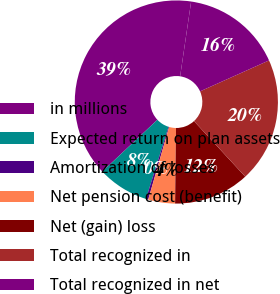<chart> <loc_0><loc_0><loc_500><loc_500><pie_chart><fcel>in millions<fcel>Expected return on plan assets<fcel>Amortization of losses<fcel>Net pension cost (benefit)<fcel>Net (gain) loss<fcel>Total recognized in<fcel>Total recognized in net<nl><fcel>39.33%<fcel>8.16%<fcel>0.37%<fcel>4.27%<fcel>12.06%<fcel>19.85%<fcel>15.96%<nl></chart> 